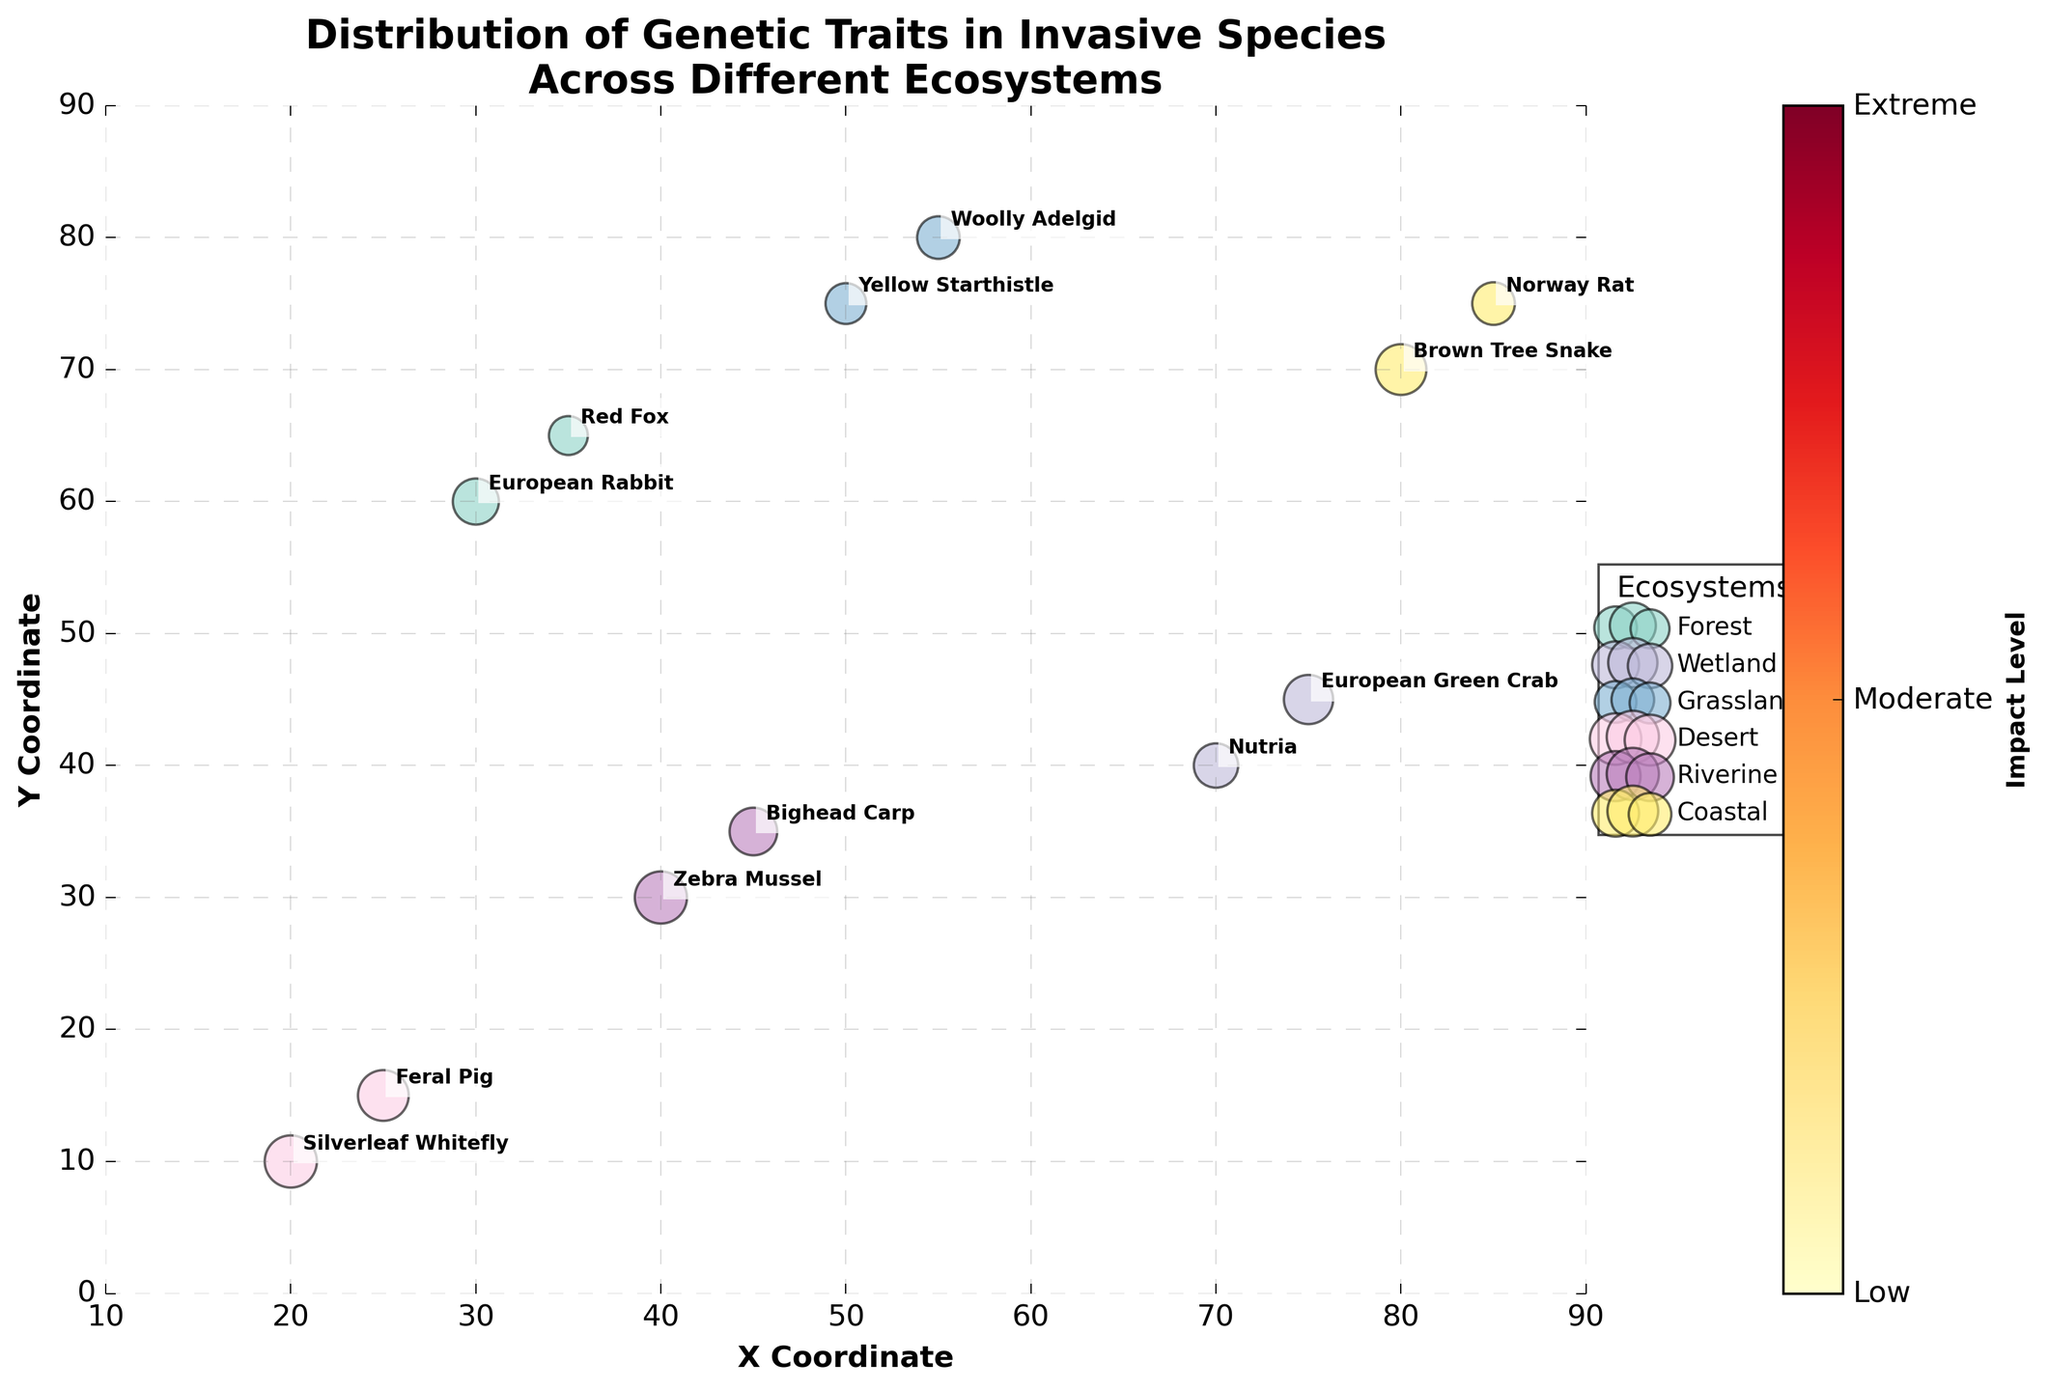Which ecosystem has the highest number of species with extreme impact levels? By observing the bubbles with the color associated with 'Extreme' impact levels, we can count the species per ecosystem: Wetland has 1, Desert has 1, Riverine has 1, and Coastal has 2. Therefore, Coastal has the highest number of species with extreme impact levels.
Answer: Coastal Which species is located at the highest Y coordinate? By looking at the Y coordinates of all the species on the Y-axis, the species with the highest Y coordinate is the Woolly Adelgid in the Grassland ecosystem, located at Y = 80.
Answer: Woolly Adelgid What is the average frequency of the species in the Forest ecosystem? In the Forest ecosystem, we have European Rabbit with a frequency of 70 and Red Fox with a frequency of 50. The average frequency is calculated as (70 + 50) / 2 = 60.
Answer: 60 What are the genetic traits of species with frequencies greater than 80? By identifying species with frequencies > 80, we get the Silverleaf Whitefly ('Herbivory'), Feral Pig ('Rooting'), Zebra Mussel ('Filter Feeding'), Bighead Carp ('Planktivory'), and Brown Tree Snake ('Predation'). All these traits are visible in the bubbles corresponding to the mentioned species.
Answer: Herbivory, Rooting, Filter Feeding, Planktivory, Predation Which species in the Coastal ecosystem has a higher impact level? By comparing the impact levels of the species in the Coastal ecosystem, Brown Tree Snake ('Extreme') and Norway Rat ('High'), Brown Tree Snake has a higher impact level.
Answer: Brown Tree Snake What is the median frequency of all species? To find the median frequency, list the frequencies of all species: 70, 50, 65, 80, 55, 60, 90, 85, 90, 75, 85, 60, the sorted list is 50, 55, 60, 60, 65, 70, 75, 80, 85, 85, 90, 90. With 12 data points, the median is the average of the 6th and 7th values: (70 + 75) / 2 = 72.5.
Answer: 72.5 Which ecosystem has the species with the highest frequency? Looking at the highest frequency, which is 90, we see it corresponds to the Silverleaf Whitefly in the Desert and Zebra Mussel in the Riverine. Both these ecosystems have the species with the highest frequency.
Answer: Desert, Riverine 